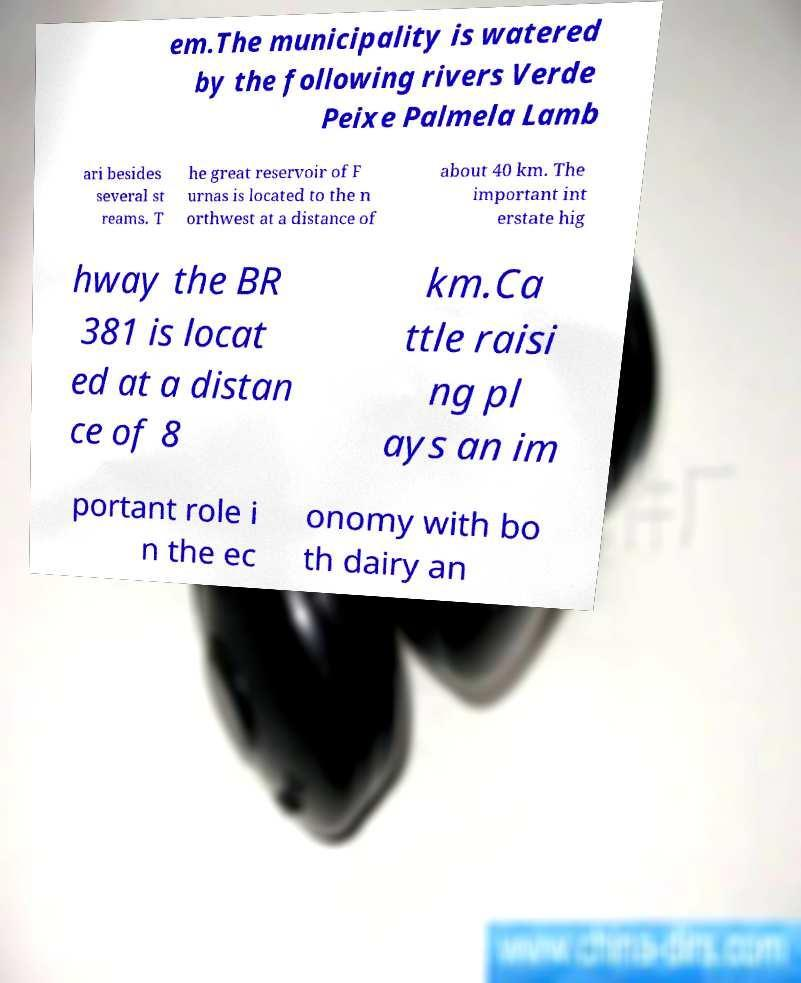Could you extract and type out the text from this image? em.The municipality is watered by the following rivers Verde Peixe Palmela Lamb ari besides several st reams. T he great reservoir of F urnas is located to the n orthwest at a distance of about 40 km. The important int erstate hig hway the BR 381 is locat ed at a distan ce of 8 km.Ca ttle raisi ng pl ays an im portant role i n the ec onomy with bo th dairy an 